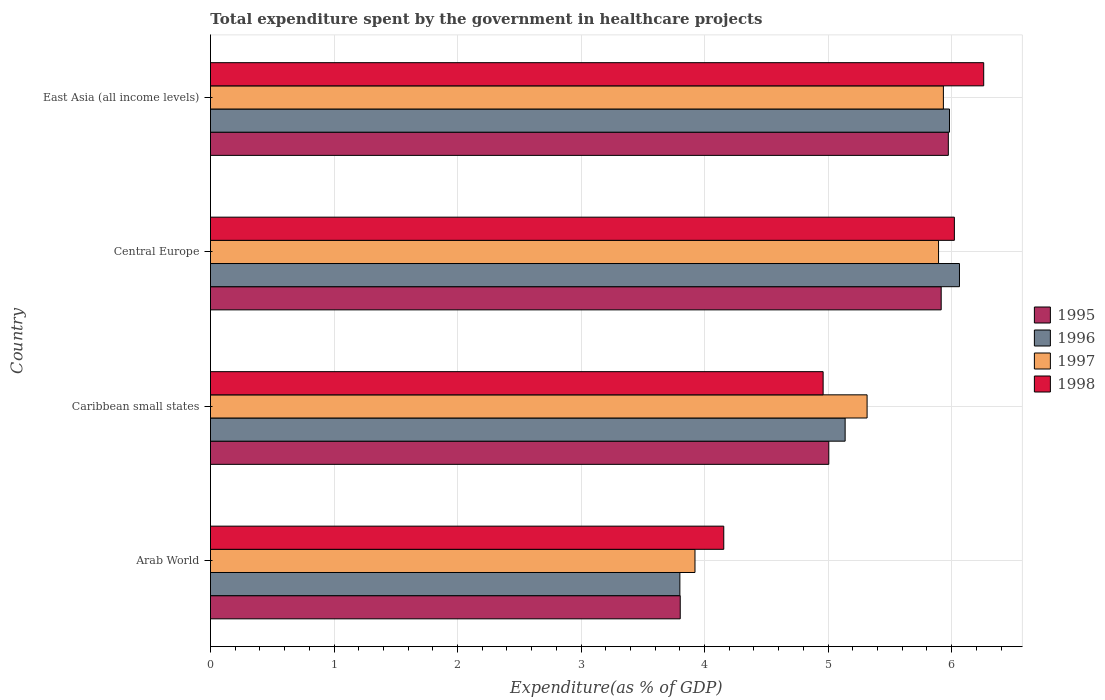How many groups of bars are there?
Your answer should be very brief. 4. Are the number of bars per tick equal to the number of legend labels?
Offer a very short reply. Yes. Are the number of bars on each tick of the Y-axis equal?
Make the answer very short. Yes. How many bars are there on the 4th tick from the top?
Your response must be concise. 4. How many bars are there on the 4th tick from the bottom?
Make the answer very short. 4. What is the label of the 2nd group of bars from the top?
Offer a very short reply. Central Europe. What is the total expenditure spent by the government in healthcare projects in 1997 in Arab World?
Provide a succinct answer. 3.92. Across all countries, what is the maximum total expenditure spent by the government in healthcare projects in 1996?
Make the answer very short. 6.06. Across all countries, what is the minimum total expenditure spent by the government in healthcare projects in 1997?
Give a very brief answer. 3.92. In which country was the total expenditure spent by the government in healthcare projects in 1998 maximum?
Give a very brief answer. East Asia (all income levels). In which country was the total expenditure spent by the government in healthcare projects in 1998 minimum?
Ensure brevity in your answer.  Arab World. What is the total total expenditure spent by the government in healthcare projects in 1998 in the graph?
Ensure brevity in your answer.  21.4. What is the difference between the total expenditure spent by the government in healthcare projects in 1997 in Arab World and that in Caribbean small states?
Your response must be concise. -1.39. What is the difference between the total expenditure spent by the government in healthcare projects in 1998 in Caribbean small states and the total expenditure spent by the government in healthcare projects in 1995 in East Asia (all income levels)?
Make the answer very short. -1.01. What is the average total expenditure spent by the government in healthcare projects in 1995 per country?
Keep it short and to the point. 5.17. What is the difference between the total expenditure spent by the government in healthcare projects in 1998 and total expenditure spent by the government in healthcare projects in 1995 in East Asia (all income levels)?
Ensure brevity in your answer.  0.29. In how many countries, is the total expenditure spent by the government in healthcare projects in 1998 greater than 4.6 %?
Provide a short and direct response. 3. What is the ratio of the total expenditure spent by the government in healthcare projects in 1996 in Arab World to that in Caribbean small states?
Provide a short and direct response. 0.74. Is the total expenditure spent by the government in healthcare projects in 1996 in Central Europe less than that in East Asia (all income levels)?
Ensure brevity in your answer.  No. Is the difference between the total expenditure spent by the government in healthcare projects in 1998 in Caribbean small states and East Asia (all income levels) greater than the difference between the total expenditure spent by the government in healthcare projects in 1995 in Caribbean small states and East Asia (all income levels)?
Give a very brief answer. No. What is the difference between the highest and the second highest total expenditure spent by the government in healthcare projects in 1998?
Keep it short and to the point. 0.24. What is the difference between the highest and the lowest total expenditure spent by the government in healthcare projects in 1997?
Give a very brief answer. 2.01. Is the sum of the total expenditure spent by the government in healthcare projects in 1995 in Arab World and Central Europe greater than the maximum total expenditure spent by the government in healthcare projects in 1996 across all countries?
Keep it short and to the point. Yes. Is it the case that in every country, the sum of the total expenditure spent by the government in healthcare projects in 1995 and total expenditure spent by the government in healthcare projects in 1997 is greater than the sum of total expenditure spent by the government in healthcare projects in 1998 and total expenditure spent by the government in healthcare projects in 1996?
Offer a terse response. No. What does the 4th bar from the top in Caribbean small states represents?
Your answer should be compact. 1995. Are all the bars in the graph horizontal?
Provide a short and direct response. Yes. Are the values on the major ticks of X-axis written in scientific E-notation?
Your response must be concise. No. How many legend labels are there?
Your answer should be compact. 4. How are the legend labels stacked?
Your response must be concise. Vertical. What is the title of the graph?
Offer a very short reply. Total expenditure spent by the government in healthcare projects. What is the label or title of the X-axis?
Offer a very short reply. Expenditure(as % of GDP). What is the Expenditure(as % of GDP) in 1995 in Arab World?
Provide a succinct answer. 3.8. What is the Expenditure(as % of GDP) in 1996 in Arab World?
Keep it short and to the point. 3.8. What is the Expenditure(as % of GDP) in 1997 in Arab World?
Your response must be concise. 3.92. What is the Expenditure(as % of GDP) of 1998 in Arab World?
Keep it short and to the point. 4.16. What is the Expenditure(as % of GDP) of 1995 in Caribbean small states?
Give a very brief answer. 5.01. What is the Expenditure(as % of GDP) of 1996 in Caribbean small states?
Your response must be concise. 5.14. What is the Expenditure(as % of GDP) of 1997 in Caribbean small states?
Your answer should be compact. 5.32. What is the Expenditure(as % of GDP) of 1998 in Caribbean small states?
Your answer should be compact. 4.96. What is the Expenditure(as % of GDP) in 1995 in Central Europe?
Your response must be concise. 5.92. What is the Expenditure(as % of GDP) of 1996 in Central Europe?
Give a very brief answer. 6.06. What is the Expenditure(as % of GDP) in 1997 in Central Europe?
Your answer should be very brief. 5.89. What is the Expenditure(as % of GDP) of 1998 in Central Europe?
Offer a very short reply. 6.02. What is the Expenditure(as % of GDP) of 1995 in East Asia (all income levels)?
Provide a short and direct response. 5.97. What is the Expenditure(as % of GDP) in 1996 in East Asia (all income levels)?
Offer a very short reply. 5.98. What is the Expenditure(as % of GDP) of 1997 in East Asia (all income levels)?
Your response must be concise. 5.93. What is the Expenditure(as % of GDP) in 1998 in East Asia (all income levels)?
Ensure brevity in your answer.  6.26. Across all countries, what is the maximum Expenditure(as % of GDP) of 1995?
Give a very brief answer. 5.97. Across all countries, what is the maximum Expenditure(as % of GDP) in 1996?
Make the answer very short. 6.06. Across all countries, what is the maximum Expenditure(as % of GDP) in 1997?
Your response must be concise. 5.93. Across all countries, what is the maximum Expenditure(as % of GDP) of 1998?
Offer a terse response. 6.26. Across all countries, what is the minimum Expenditure(as % of GDP) of 1995?
Keep it short and to the point. 3.8. Across all countries, what is the minimum Expenditure(as % of GDP) in 1996?
Ensure brevity in your answer.  3.8. Across all countries, what is the minimum Expenditure(as % of GDP) of 1997?
Offer a very short reply. 3.92. Across all countries, what is the minimum Expenditure(as % of GDP) of 1998?
Make the answer very short. 4.16. What is the total Expenditure(as % of GDP) of 1995 in the graph?
Your response must be concise. 20.7. What is the total Expenditure(as % of GDP) in 1996 in the graph?
Offer a terse response. 20.98. What is the total Expenditure(as % of GDP) of 1997 in the graph?
Provide a short and direct response. 21.07. What is the total Expenditure(as % of GDP) of 1998 in the graph?
Give a very brief answer. 21.4. What is the difference between the Expenditure(as % of GDP) of 1995 in Arab World and that in Caribbean small states?
Ensure brevity in your answer.  -1.2. What is the difference between the Expenditure(as % of GDP) in 1996 in Arab World and that in Caribbean small states?
Make the answer very short. -1.34. What is the difference between the Expenditure(as % of GDP) in 1997 in Arab World and that in Caribbean small states?
Provide a short and direct response. -1.39. What is the difference between the Expenditure(as % of GDP) of 1998 in Arab World and that in Caribbean small states?
Offer a very short reply. -0.8. What is the difference between the Expenditure(as % of GDP) in 1995 in Arab World and that in Central Europe?
Provide a succinct answer. -2.11. What is the difference between the Expenditure(as % of GDP) of 1996 in Arab World and that in Central Europe?
Your answer should be compact. -2.26. What is the difference between the Expenditure(as % of GDP) of 1997 in Arab World and that in Central Europe?
Offer a terse response. -1.97. What is the difference between the Expenditure(as % of GDP) in 1998 in Arab World and that in Central Europe?
Give a very brief answer. -1.87. What is the difference between the Expenditure(as % of GDP) in 1995 in Arab World and that in East Asia (all income levels)?
Your response must be concise. -2.17. What is the difference between the Expenditure(as % of GDP) of 1996 in Arab World and that in East Asia (all income levels)?
Offer a terse response. -2.18. What is the difference between the Expenditure(as % of GDP) in 1997 in Arab World and that in East Asia (all income levels)?
Keep it short and to the point. -2.01. What is the difference between the Expenditure(as % of GDP) of 1998 in Arab World and that in East Asia (all income levels)?
Your response must be concise. -2.1. What is the difference between the Expenditure(as % of GDP) of 1995 in Caribbean small states and that in Central Europe?
Provide a short and direct response. -0.91. What is the difference between the Expenditure(as % of GDP) of 1996 in Caribbean small states and that in Central Europe?
Offer a very short reply. -0.93. What is the difference between the Expenditure(as % of GDP) of 1997 in Caribbean small states and that in Central Europe?
Ensure brevity in your answer.  -0.58. What is the difference between the Expenditure(as % of GDP) of 1998 in Caribbean small states and that in Central Europe?
Provide a succinct answer. -1.06. What is the difference between the Expenditure(as % of GDP) in 1995 in Caribbean small states and that in East Asia (all income levels)?
Give a very brief answer. -0.97. What is the difference between the Expenditure(as % of GDP) of 1996 in Caribbean small states and that in East Asia (all income levels)?
Make the answer very short. -0.84. What is the difference between the Expenditure(as % of GDP) of 1997 in Caribbean small states and that in East Asia (all income levels)?
Your answer should be very brief. -0.62. What is the difference between the Expenditure(as % of GDP) of 1998 in Caribbean small states and that in East Asia (all income levels)?
Ensure brevity in your answer.  -1.3. What is the difference between the Expenditure(as % of GDP) of 1995 in Central Europe and that in East Asia (all income levels)?
Give a very brief answer. -0.06. What is the difference between the Expenditure(as % of GDP) of 1996 in Central Europe and that in East Asia (all income levels)?
Provide a short and direct response. 0.08. What is the difference between the Expenditure(as % of GDP) of 1997 in Central Europe and that in East Asia (all income levels)?
Make the answer very short. -0.04. What is the difference between the Expenditure(as % of GDP) of 1998 in Central Europe and that in East Asia (all income levels)?
Offer a very short reply. -0.24. What is the difference between the Expenditure(as % of GDP) in 1995 in Arab World and the Expenditure(as % of GDP) in 1996 in Caribbean small states?
Keep it short and to the point. -1.33. What is the difference between the Expenditure(as % of GDP) in 1995 in Arab World and the Expenditure(as % of GDP) in 1997 in Caribbean small states?
Provide a short and direct response. -1.51. What is the difference between the Expenditure(as % of GDP) of 1995 in Arab World and the Expenditure(as % of GDP) of 1998 in Caribbean small states?
Keep it short and to the point. -1.16. What is the difference between the Expenditure(as % of GDP) of 1996 in Arab World and the Expenditure(as % of GDP) of 1997 in Caribbean small states?
Offer a very short reply. -1.52. What is the difference between the Expenditure(as % of GDP) of 1996 in Arab World and the Expenditure(as % of GDP) of 1998 in Caribbean small states?
Give a very brief answer. -1.16. What is the difference between the Expenditure(as % of GDP) of 1997 in Arab World and the Expenditure(as % of GDP) of 1998 in Caribbean small states?
Your answer should be compact. -1.04. What is the difference between the Expenditure(as % of GDP) of 1995 in Arab World and the Expenditure(as % of GDP) of 1996 in Central Europe?
Make the answer very short. -2.26. What is the difference between the Expenditure(as % of GDP) of 1995 in Arab World and the Expenditure(as % of GDP) of 1997 in Central Europe?
Ensure brevity in your answer.  -2.09. What is the difference between the Expenditure(as % of GDP) of 1995 in Arab World and the Expenditure(as % of GDP) of 1998 in Central Europe?
Make the answer very short. -2.22. What is the difference between the Expenditure(as % of GDP) of 1996 in Arab World and the Expenditure(as % of GDP) of 1997 in Central Europe?
Your response must be concise. -2.09. What is the difference between the Expenditure(as % of GDP) in 1996 in Arab World and the Expenditure(as % of GDP) in 1998 in Central Europe?
Your answer should be compact. -2.22. What is the difference between the Expenditure(as % of GDP) of 1995 in Arab World and the Expenditure(as % of GDP) of 1996 in East Asia (all income levels)?
Your answer should be compact. -2.18. What is the difference between the Expenditure(as % of GDP) in 1995 in Arab World and the Expenditure(as % of GDP) in 1997 in East Asia (all income levels)?
Your answer should be very brief. -2.13. What is the difference between the Expenditure(as % of GDP) of 1995 in Arab World and the Expenditure(as % of GDP) of 1998 in East Asia (all income levels)?
Keep it short and to the point. -2.46. What is the difference between the Expenditure(as % of GDP) of 1996 in Arab World and the Expenditure(as % of GDP) of 1997 in East Asia (all income levels)?
Your answer should be compact. -2.13. What is the difference between the Expenditure(as % of GDP) in 1996 in Arab World and the Expenditure(as % of GDP) in 1998 in East Asia (all income levels)?
Your answer should be compact. -2.46. What is the difference between the Expenditure(as % of GDP) of 1997 in Arab World and the Expenditure(as % of GDP) of 1998 in East Asia (all income levels)?
Offer a very short reply. -2.34. What is the difference between the Expenditure(as % of GDP) in 1995 in Caribbean small states and the Expenditure(as % of GDP) in 1996 in Central Europe?
Give a very brief answer. -1.06. What is the difference between the Expenditure(as % of GDP) of 1995 in Caribbean small states and the Expenditure(as % of GDP) of 1997 in Central Europe?
Offer a terse response. -0.89. What is the difference between the Expenditure(as % of GDP) of 1995 in Caribbean small states and the Expenditure(as % of GDP) of 1998 in Central Europe?
Your answer should be compact. -1.02. What is the difference between the Expenditure(as % of GDP) of 1996 in Caribbean small states and the Expenditure(as % of GDP) of 1997 in Central Europe?
Give a very brief answer. -0.76. What is the difference between the Expenditure(as % of GDP) in 1996 in Caribbean small states and the Expenditure(as % of GDP) in 1998 in Central Europe?
Make the answer very short. -0.88. What is the difference between the Expenditure(as % of GDP) of 1997 in Caribbean small states and the Expenditure(as % of GDP) of 1998 in Central Europe?
Give a very brief answer. -0.71. What is the difference between the Expenditure(as % of GDP) in 1995 in Caribbean small states and the Expenditure(as % of GDP) in 1996 in East Asia (all income levels)?
Give a very brief answer. -0.98. What is the difference between the Expenditure(as % of GDP) of 1995 in Caribbean small states and the Expenditure(as % of GDP) of 1997 in East Asia (all income levels)?
Ensure brevity in your answer.  -0.93. What is the difference between the Expenditure(as % of GDP) in 1995 in Caribbean small states and the Expenditure(as % of GDP) in 1998 in East Asia (all income levels)?
Your answer should be very brief. -1.25. What is the difference between the Expenditure(as % of GDP) in 1996 in Caribbean small states and the Expenditure(as % of GDP) in 1997 in East Asia (all income levels)?
Provide a succinct answer. -0.8. What is the difference between the Expenditure(as % of GDP) of 1996 in Caribbean small states and the Expenditure(as % of GDP) of 1998 in East Asia (all income levels)?
Provide a succinct answer. -1.12. What is the difference between the Expenditure(as % of GDP) of 1997 in Caribbean small states and the Expenditure(as % of GDP) of 1998 in East Asia (all income levels)?
Provide a succinct answer. -0.94. What is the difference between the Expenditure(as % of GDP) of 1995 in Central Europe and the Expenditure(as % of GDP) of 1996 in East Asia (all income levels)?
Your response must be concise. -0.07. What is the difference between the Expenditure(as % of GDP) of 1995 in Central Europe and the Expenditure(as % of GDP) of 1997 in East Asia (all income levels)?
Make the answer very short. -0.02. What is the difference between the Expenditure(as % of GDP) in 1995 in Central Europe and the Expenditure(as % of GDP) in 1998 in East Asia (all income levels)?
Your answer should be compact. -0.34. What is the difference between the Expenditure(as % of GDP) in 1996 in Central Europe and the Expenditure(as % of GDP) in 1997 in East Asia (all income levels)?
Your response must be concise. 0.13. What is the difference between the Expenditure(as % of GDP) in 1996 in Central Europe and the Expenditure(as % of GDP) in 1998 in East Asia (all income levels)?
Provide a short and direct response. -0.2. What is the difference between the Expenditure(as % of GDP) in 1997 in Central Europe and the Expenditure(as % of GDP) in 1998 in East Asia (all income levels)?
Offer a very short reply. -0.37. What is the average Expenditure(as % of GDP) of 1995 per country?
Keep it short and to the point. 5.17. What is the average Expenditure(as % of GDP) in 1996 per country?
Provide a short and direct response. 5.25. What is the average Expenditure(as % of GDP) of 1997 per country?
Give a very brief answer. 5.27. What is the average Expenditure(as % of GDP) of 1998 per country?
Offer a terse response. 5.35. What is the difference between the Expenditure(as % of GDP) of 1995 and Expenditure(as % of GDP) of 1996 in Arab World?
Your answer should be compact. 0. What is the difference between the Expenditure(as % of GDP) of 1995 and Expenditure(as % of GDP) of 1997 in Arab World?
Give a very brief answer. -0.12. What is the difference between the Expenditure(as % of GDP) of 1995 and Expenditure(as % of GDP) of 1998 in Arab World?
Ensure brevity in your answer.  -0.35. What is the difference between the Expenditure(as % of GDP) in 1996 and Expenditure(as % of GDP) in 1997 in Arab World?
Your answer should be compact. -0.12. What is the difference between the Expenditure(as % of GDP) of 1996 and Expenditure(as % of GDP) of 1998 in Arab World?
Provide a succinct answer. -0.36. What is the difference between the Expenditure(as % of GDP) of 1997 and Expenditure(as % of GDP) of 1998 in Arab World?
Your answer should be compact. -0.23. What is the difference between the Expenditure(as % of GDP) of 1995 and Expenditure(as % of GDP) of 1996 in Caribbean small states?
Offer a very short reply. -0.13. What is the difference between the Expenditure(as % of GDP) in 1995 and Expenditure(as % of GDP) in 1997 in Caribbean small states?
Offer a very short reply. -0.31. What is the difference between the Expenditure(as % of GDP) of 1995 and Expenditure(as % of GDP) of 1998 in Caribbean small states?
Your answer should be very brief. 0.05. What is the difference between the Expenditure(as % of GDP) in 1996 and Expenditure(as % of GDP) in 1997 in Caribbean small states?
Your answer should be very brief. -0.18. What is the difference between the Expenditure(as % of GDP) of 1996 and Expenditure(as % of GDP) of 1998 in Caribbean small states?
Offer a terse response. 0.18. What is the difference between the Expenditure(as % of GDP) in 1997 and Expenditure(as % of GDP) in 1998 in Caribbean small states?
Your answer should be very brief. 0.36. What is the difference between the Expenditure(as % of GDP) of 1995 and Expenditure(as % of GDP) of 1996 in Central Europe?
Give a very brief answer. -0.15. What is the difference between the Expenditure(as % of GDP) in 1995 and Expenditure(as % of GDP) in 1997 in Central Europe?
Make the answer very short. 0.02. What is the difference between the Expenditure(as % of GDP) in 1995 and Expenditure(as % of GDP) in 1998 in Central Europe?
Make the answer very short. -0.11. What is the difference between the Expenditure(as % of GDP) in 1996 and Expenditure(as % of GDP) in 1997 in Central Europe?
Keep it short and to the point. 0.17. What is the difference between the Expenditure(as % of GDP) in 1996 and Expenditure(as % of GDP) in 1998 in Central Europe?
Provide a short and direct response. 0.04. What is the difference between the Expenditure(as % of GDP) in 1997 and Expenditure(as % of GDP) in 1998 in Central Europe?
Your answer should be very brief. -0.13. What is the difference between the Expenditure(as % of GDP) of 1995 and Expenditure(as % of GDP) of 1996 in East Asia (all income levels)?
Offer a very short reply. -0.01. What is the difference between the Expenditure(as % of GDP) in 1995 and Expenditure(as % of GDP) in 1997 in East Asia (all income levels)?
Ensure brevity in your answer.  0.04. What is the difference between the Expenditure(as % of GDP) in 1995 and Expenditure(as % of GDP) in 1998 in East Asia (all income levels)?
Your answer should be very brief. -0.29. What is the difference between the Expenditure(as % of GDP) in 1996 and Expenditure(as % of GDP) in 1997 in East Asia (all income levels)?
Your answer should be compact. 0.05. What is the difference between the Expenditure(as % of GDP) in 1996 and Expenditure(as % of GDP) in 1998 in East Asia (all income levels)?
Offer a terse response. -0.28. What is the difference between the Expenditure(as % of GDP) of 1997 and Expenditure(as % of GDP) of 1998 in East Asia (all income levels)?
Your answer should be very brief. -0.33. What is the ratio of the Expenditure(as % of GDP) of 1995 in Arab World to that in Caribbean small states?
Give a very brief answer. 0.76. What is the ratio of the Expenditure(as % of GDP) of 1996 in Arab World to that in Caribbean small states?
Your answer should be very brief. 0.74. What is the ratio of the Expenditure(as % of GDP) of 1997 in Arab World to that in Caribbean small states?
Your answer should be very brief. 0.74. What is the ratio of the Expenditure(as % of GDP) in 1998 in Arab World to that in Caribbean small states?
Ensure brevity in your answer.  0.84. What is the ratio of the Expenditure(as % of GDP) in 1995 in Arab World to that in Central Europe?
Offer a very short reply. 0.64. What is the ratio of the Expenditure(as % of GDP) in 1996 in Arab World to that in Central Europe?
Your answer should be very brief. 0.63. What is the ratio of the Expenditure(as % of GDP) of 1997 in Arab World to that in Central Europe?
Give a very brief answer. 0.67. What is the ratio of the Expenditure(as % of GDP) in 1998 in Arab World to that in Central Europe?
Your answer should be compact. 0.69. What is the ratio of the Expenditure(as % of GDP) of 1995 in Arab World to that in East Asia (all income levels)?
Offer a terse response. 0.64. What is the ratio of the Expenditure(as % of GDP) in 1996 in Arab World to that in East Asia (all income levels)?
Keep it short and to the point. 0.64. What is the ratio of the Expenditure(as % of GDP) in 1997 in Arab World to that in East Asia (all income levels)?
Ensure brevity in your answer.  0.66. What is the ratio of the Expenditure(as % of GDP) of 1998 in Arab World to that in East Asia (all income levels)?
Offer a terse response. 0.66. What is the ratio of the Expenditure(as % of GDP) in 1995 in Caribbean small states to that in Central Europe?
Provide a short and direct response. 0.85. What is the ratio of the Expenditure(as % of GDP) in 1996 in Caribbean small states to that in Central Europe?
Ensure brevity in your answer.  0.85. What is the ratio of the Expenditure(as % of GDP) in 1997 in Caribbean small states to that in Central Europe?
Offer a terse response. 0.9. What is the ratio of the Expenditure(as % of GDP) in 1998 in Caribbean small states to that in Central Europe?
Make the answer very short. 0.82. What is the ratio of the Expenditure(as % of GDP) in 1995 in Caribbean small states to that in East Asia (all income levels)?
Ensure brevity in your answer.  0.84. What is the ratio of the Expenditure(as % of GDP) of 1996 in Caribbean small states to that in East Asia (all income levels)?
Your answer should be compact. 0.86. What is the ratio of the Expenditure(as % of GDP) in 1997 in Caribbean small states to that in East Asia (all income levels)?
Ensure brevity in your answer.  0.9. What is the ratio of the Expenditure(as % of GDP) in 1998 in Caribbean small states to that in East Asia (all income levels)?
Your response must be concise. 0.79. What is the ratio of the Expenditure(as % of GDP) in 1995 in Central Europe to that in East Asia (all income levels)?
Give a very brief answer. 0.99. What is the ratio of the Expenditure(as % of GDP) of 1996 in Central Europe to that in East Asia (all income levels)?
Offer a terse response. 1.01. What is the ratio of the Expenditure(as % of GDP) in 1997 in Central Europe to that in East Asia (all income levels)?
Ensure brevity in your answer.  0.99. What is the ratio of the Expenditure(as % of GDP) of 1998 in Central Europe to that in East Asia (all income levels)?
Give a very brief answer. 0.96. What is the difference between the highest and the second highest Expenditure(as % of GDP) of 1995?
Offer a very short reply. 0.06. What is the difference between the highest and the second highest Expenditure(as % of GDP) in 1996?
Your answer should be compact. 0.08. What is the difference between the highest and the second highest Expenditure(as % of GDP) of 1997?
Your response must be concise. 0.04. What is the difference between the highest and the second highest Expenditure(as % of GDP) in 1998?
Keep it short and to the point. 0.24. What is the difference between the highest and the lowest Expenditure(as % of GDP) of 1995?
Your answer should be compact. 2.17. What is the difference between the highest and the lowest Expenditure(as % of GDP) of 1996?
Offer a very short reply. 2.26. What is the difference between the highest and the lowest Expenditure(as % of GDP) of 1997?
Ensure brevity in your answer.  2.01. What is the difference between the highest and the lowest Expenditure(as % of GDP) of 1998?
Your answer should be very brief. 2.1. 